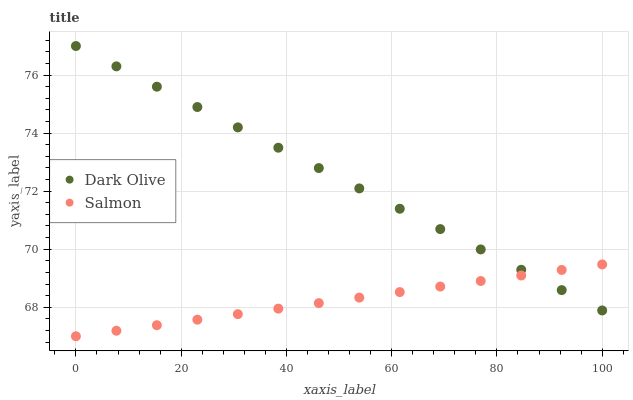Does Salmon have the minimum area under the curve?
Answer yes or no. Yes. Does Dark Olive have the maximum area under the curve?
Answer yes or no. Yes. Does Salmon have the maximum area under the curve?
Answer yes or no. No. Is Dark Olive the smoothest?
Answer yes or no. Yes. Is Salmon the roughest?
Answer yes or no. Yes. Is Salmon the smoothest?
Answer yes or no. No. Does Salmon have the lowest value?
Answer yes or no. Yes. Does Dark Olive have the highest value?
Answer yes or no. Yes. Does Salmon have the highest value?
Answer yes or no. No. Does Dark Olive intersect Salmon?
Answer yes or no. Yes. Is Dark Olive less than Salmon?
Answer yes or no. No. Is Dark Olive greater than Salmon?
Answer yes or no. No. 